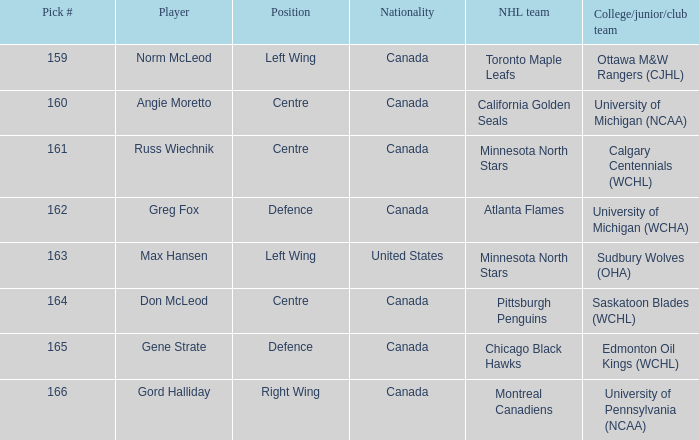What team did Russ Wiechnik, on the centre position, come from? Calgary Centennials (WCHL). 